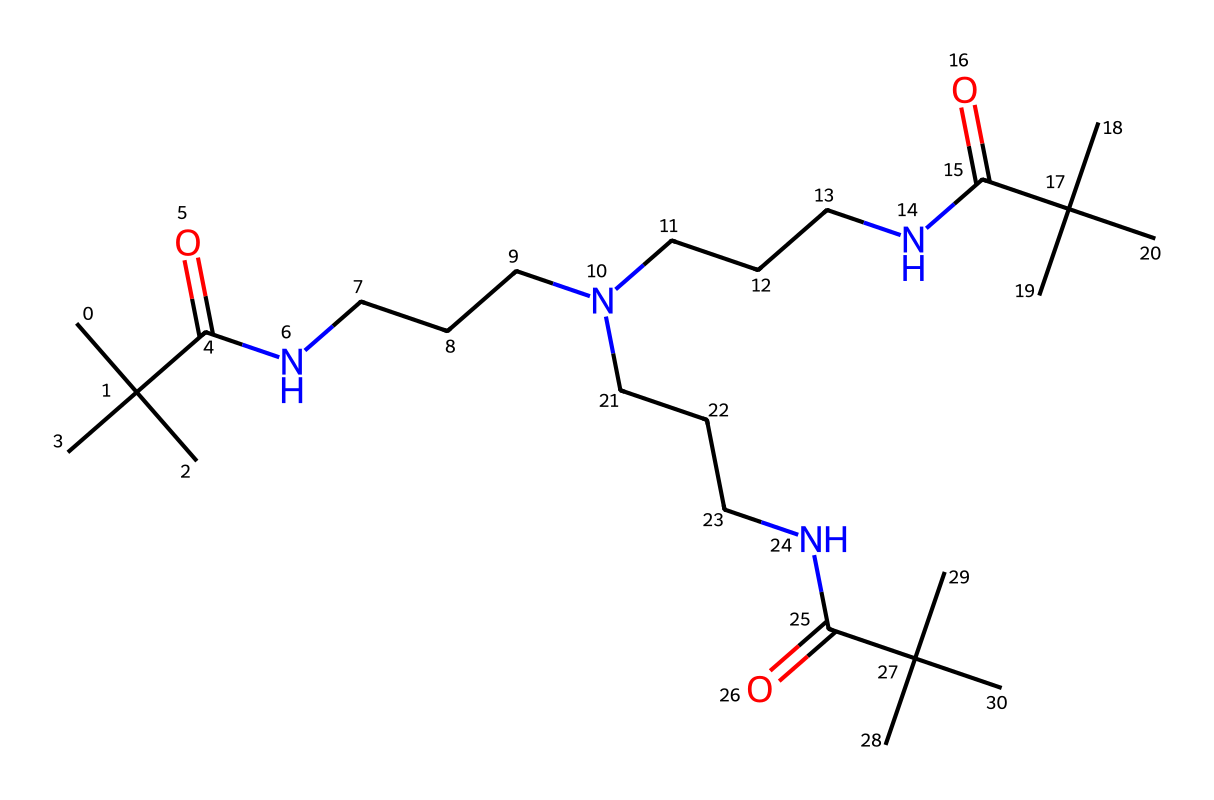How many nitrogen atoms are present in this structure? By examining the provided SMILES representation, we can identify the elements within the chemical structure. Each 'N' corresponds to a nitrogen atom. Counting the occurrences, we find there are four nitrogen atoms present.
Answer: four What functional groups can be identified in this chemical? In the SMILES structure, we can look for common functional groups. The presence of 'N' indicates amine functionalities, and the 'C(=O)' demonstrates the presence of amide (or carbonyl) groups. Thus, the chemical contains amides and amines.
Answer: amides and amines What is the primary use of this chemical in elastic bandages? The structure suggests that this chemical is a type of polyether or polyamide, known for its elasticity and stretchability. This polyfunctional aspect makes it suitable for applications requiring flexible materials, such as elastic bandages.
Answer: elasticity How many carbon atoms are in this chemical? To determine the number of carbon atoms, we count the 'C' symbols in the SMILES string. After counting, we find there are a total of 20 carbon atoms in the structure.
Answer: twenty What type of polymer is formed from this chemical? This chemical is made up of repeating units that are characteristic of polyurethanes, derived from the presence of amine and carbonyl functional groups. Therefore, it forms a polyurethane polymer.
Answer: polyurethane How does the presence of nitrogen contribute to the properties of this chemical? Nitrogen atoms in the chemical provide sites for hydrogen bonding and influence the solubility, flexibility, and strength of the polymer. This is crucial for the elasticity and overall performance of spandex in elastic bandages.
Answer: elasticity and strength 